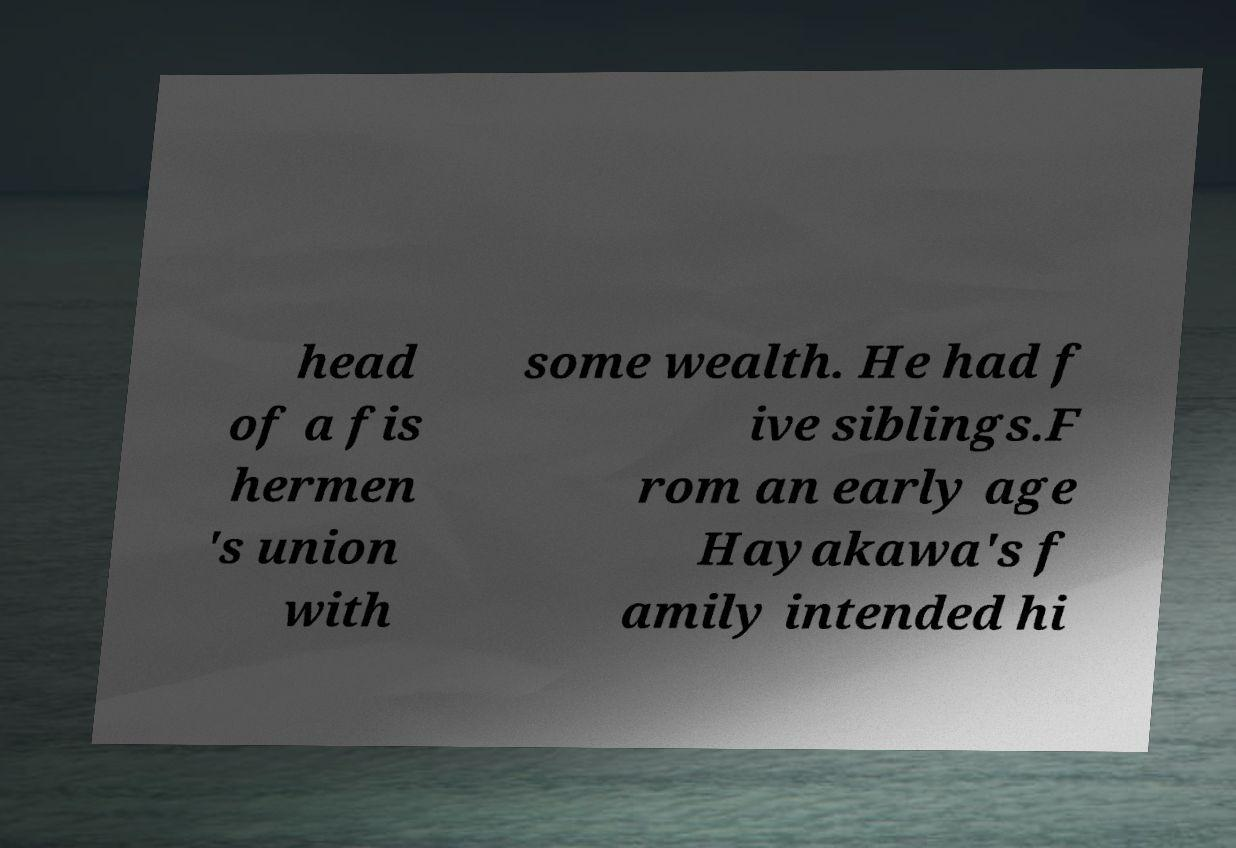Could you extract and type out the text from this image? head of a fis hermen 's union with some wealth. He had f ive siblings.F rom an early age Hayakawa's f amily intended hi 